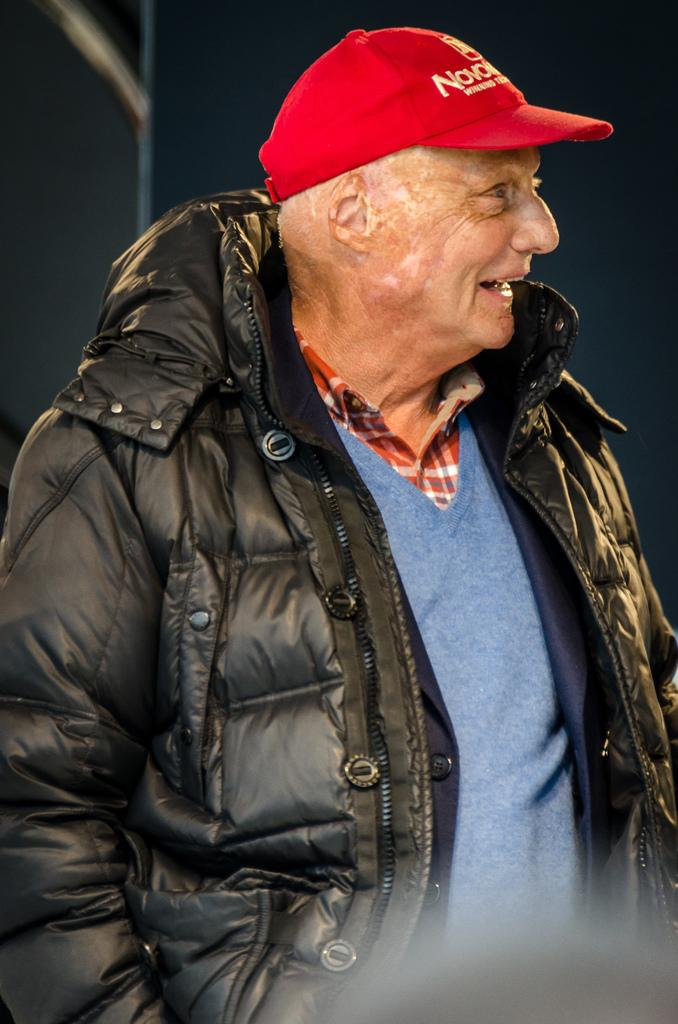What is the main subject of the image? The main subject of the image is a man. What is the man doing in the image? The man is standing in the image. What is the man wearing on his head? The man is wearing a cap in the image. What color is the jacket the man is wearing? The man is wearing a black jacket in the image. What can be observed about the background of the image? The background of the image is dark. What type of kite is the man holding in the image? There is no kite present in the image; the man is wearing a cap and a black jacket while standing. How many pages of the book can be seen in the image? There is no book present in the image; the main subject is a man wearing a cap and a black jacket while standing. 